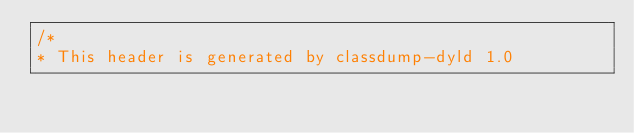Convert code to text. <code><loc_0><loc_0><loc_500><loc_500><_C_>/*
* This header is generated by classdump-dyld 1.0</code> 